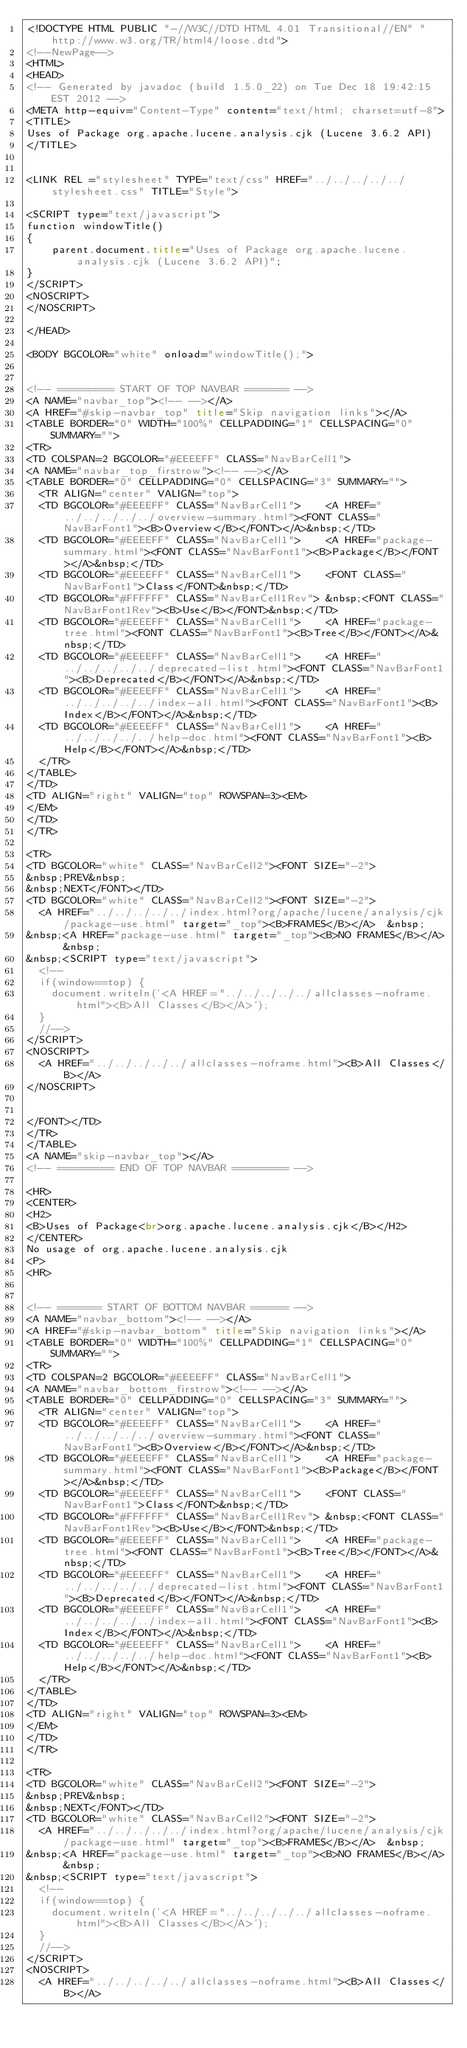Convert code to text. <code><loc_0><loc_0><loc_500><loc_500><_HTML_><!DOCTYPE HTML PUBLIC "-//W3C//DTD HTML 4.01 Transitional//EN" "http://www.w3.org/TR/html4/loose.dtd">
<!--NewPage-->
<HTML>
<HEAD>
<!-- Generated by javadoc (build 1.5.0_22) on Tue Dec 18 19:42:15 EST 2012 -->
<META http-equiv="Content-Type" content="text/html; charset=utf-8">
<TITLE>
Uses of Package org.apache.lucene.analysis.cjk (Lucene 3.6.2 API)
</TITLE>


<LINK REL ="stylesheet" TYPE="text/css" HREF="../../../../../stylesheet.css" TITLE="Style">

<SCRIPT type="text/javascript">
function windowTitle()
{
    parent.document.title="Uses of Package org.apache.lucene.analysis.cjk (Lucene 3.6.2 API)";
}
</SCRIPT>
<NOSCRIPT>
</NOSCRIPT>

</HEAD>

<BODY BGCOLOR="white" onload="windowTitle();">


<!-- ========= START OF TOP NAVBAR ======= -->
<A NAME="navbar_top"><!-- --></A>
<A HREF="#skip-navbar_top" title="Skip navigation links"></A>
<TABLE BORDER="0" WIDTH="100%" CELLPADDING="1" CELLSPACING="0" SUMMARY="">
<TR>
<TD COLSPAN=2 BGCOLOR="#EEEEFF" CLASS="NavBarCell1">
<A NAME="navbar_top_firstrow"><!-- --></A>
<TABLE BORDER="0" CELLPADDING="0" CELLSPACING="3" SUMMARY="">
  <TR ALIGN="center" VALIGN="top">
  <TD BGCOLOR="#EEEEFF" CLASS="NavBarCell1">    <A HREF="../../../../../overview-summary.html"><FONT CLASS="NavBarFont1"><B>Overview</B></FONT></A>&nbsp;</TD>
  <TD BGCOLOR="#EEEEFF" CLASS="NavBarCell1">    <A HREF="package-summary.html"><FONT CLASS="NavBarFont1"><B>Package</B></FONT></A>&nbsp;</TD>
  <TD BGCOLOR="#EEEEFF" CLASS="NavBarCell1">    <FONT CLASS="NavBarFont1">Class</FONT>&nbsp;</TD>
  <TD BGCOLOR="#FFFFFF" CLASS="NavBarCell1Rev"> &nbsp;<FONT CLASS="NavBarFont1Rev"><B>Use</B></FONT>&nbsp;</TD>
  <TD BGCOLOR="#EEEEFF" CLASS="NavBarCell1">    <A HREF="package-tree.html"><FONT CLASS="NavBarFont1"><B>Tree</B></FONT></A>&nbsp;</TD>
  <TD BGCOLOR="#EEEEFF" CLASS="NavBarCell1">    <A HREF="../../../../../deprecated-list.html"><FONT CLASS="NavBarFont1"><B>Deprecated</B></FONT></A>&nbsp;</TD>
  <TD BGCOLOR="#EEEEFF" CLASS="NavBarCell1">    <A HREF="../../../../../index-all.html"><FONT CLASS="NavBarFont1"><B>Index</B></FONT></A>&nbsp;</TD>
  <TD BGCOLOR="#EEEEFF" CLASS="NavBarCell1">    <A HREF="../../../../../help-doc.html"><FONT CLASS="NavBarFont1"><B>Help</B></FONT></A>&nbsp;</TD>
  </TR>
</TABLE>
</TD>
<TD ALIGN="right" VALIGN="top" ROWSPAN=3><EM>
</EM>
</TD>
</TR>

<TR>
<TD BGCOLOR="white" CLASS="NavBarCell2"><FONT SIZE="-2">
&nbsp;PREV&nbsp;
&nbsp;NEXT</FONT></TD>
<TD BGCOLOR="white" CLASS="NavBarCell2"><FONT SIZE="-2">
  <A HREF="../../../../../index.html?org/apache/lucene/analysis/cjk/package-use.html" target="_top"><B>FRAMES</B></A>  &nbsp;
&nbsp;<A HREF="package-use.html" target="_top"><B>NO FRAMES</B></A>  &nbsp;
&nbsp;<SCRIPT type="text/javascript">
  <!--
  if(window==top) {
    document.writeln('<A HREF="../../../../../allclasses-noframe.html"><B>All Classes</B></A>');
  }
  //-->
</SCRIPT>
<NOSCRIPT>
  <A HREF="../../../../../allclasses-noframe.html"><B>All Classes</B></A>
</NOSCRIPT>


</FONT></TD>
</TR>
</TABLE>
<A NAME="skip-navbar_top"></A>
<!-- ========= END OF TOP NAVBAR ========= -->

<HR>
<CENTER>
<H2>
<B>Uses of Package<br>org.apache.lucene.analysis.cjk</B></H2>
</CENTER>
No usage of org.apache.lucene.analysis.cjk
<P>
<HR>


<!-- ======= START OF BOTTOM NAVBAR ====== -->
<A NAME="navbar_bottom"><!-- --></A>
<A HREF="#skip-navbar_bottom" title="Skip navigation links"></A>
<TABLE BORDER="0" WIDTH="100%" CELLPADDING="1" CELLSPACING="0" SUMMARY="">
<TR>
<TD COLSPAN=2 BGCOLOR="#EEEEFF" CLASS="NavBarCell1">
<A NAME="navbar_bottom_firstrow"><!-- --></A>
<TABLE BORDER="0" CELLPADDING="0" CELLSPACING="3" SUMMARY="">
  <TR ALIGN="center" VALIGN="top">
  <TD BGCOLOR="#EEEEFF" CLASS="NavBarCell1">    <A HREF="../../../../../overview-summary.html"><FONT CLASS="NavBarFont1"><B>Overview</B></FONT></A>&nbsp;</TD>
  <TD BGCOLOR="#EEEEFF" CLASS="NavBarCell1">    <A HREF="package-summary.html"><FONT CLASS="NavBarFont1"><B>Package</B></FONT></A>&nbsp;</TD>
  <TD BGCOLOR="#EEEEFF" CLASS="NavBarCell1">    <FONT CLASS="NavBarFont1">Class</FONT>&nbsp;</TD>
  <TD BGCOLOR="#FFFFFF" CLASS="NavBarCell1Rev"> &nbsp;<FONT CLASS="NavBarFont1Rev"><B>Use</B></FONT>&nbsp;</TD>
  <TD BGCOLOR="#EEEEFF" CLASS="NavBarCell1">    <A HREF="package-tree.html"><FONT CLASS="NavBarFont1"><B>Tree</B></FONT></A>&nbsp;</TD>
  <TD BGCOLOR="#EEEEFF" CLASS="NavBarCell1">    <A HREF="../../../../../deprecated-list.html"><FONT CLASS="NavBarFont1"><B>Deprecated</B></FONT></A>&nbsp;</TD>
  <TD BGCOLOR="#EEEEFF" CLASS="NavBarCell1">    <A HREF="../../../../../index-all.html"><FONT CLASS="NavBarFont1"><B>Index</B></FONT></A>&nbsp;</TD>
  <TD BGCOLOR="#EEEEFF" CLASS="NavBarCell1">    <A HREF="../../../../../help-doc.html"><FONT CLASS="NavBarFont1"><B>Help</B></FONT></A>&nbsp;</TD>
  </TR>
</TABLE>
</TD>
<TD ALIGN="right" VALIGN="top" ROWSPAN=3><EM>
</EM>
</TD>
</TR>

<TR>
<TD BGCOLOR="white" CLASS="NavBarCell2"><FONT SIZE="-2">
&nbsp;PREV&nbsp;
&nbsp;NEXT</FONT></TD>
<TD BGCOLOR="white" CLASS="NavBarCell2"><FONT SIZE="-2">
  <A HREF="../../../../../index.html?org/apache/lucene/analysis/cjk/package-use.html" target="_top"><B>FRAMES</B></A>  &nbsp;
&nbsp;<A HREF="package-use.html" target="_top"><B>NO FRAMES</B></A>  &nbsp;
&nbsp;<SCRIPT type="text/javascript">
  <!--
  if(window==top) {
    document.writeln('<A HREF="../../../../../allclasses-noframe.html"><B>All Classes</B></A>');
  }
  //-->
</SCRIPT>
<NOSCRIPT>
  <A HREF="../../../../../allclasses-noframe.html"><B>All Classes</B></A></code> 